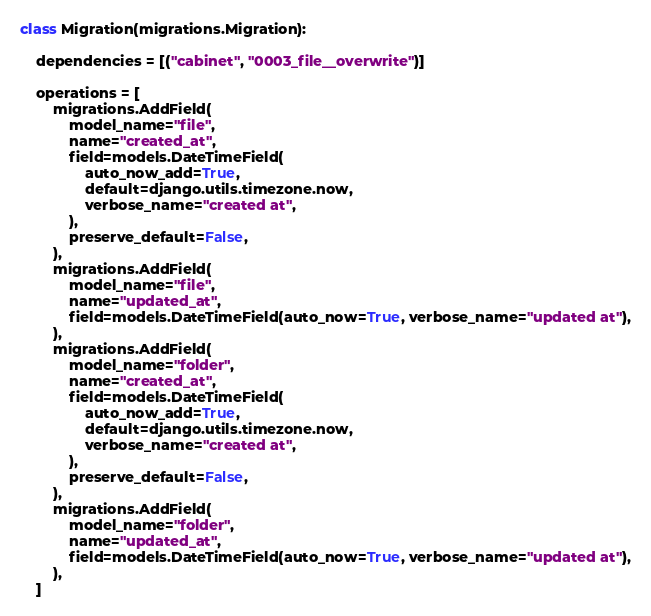<code> <loc_0><loc_0><loc_500><loc_500><_Python_>

class Migration(migrations.Migration):

    dependencies = [("cabinet", "0003_file__overwrite")]

    operations = [
        migrations.AddField(
            model_name="file",
            name="created_at",
            field=models.DateTimeField(
                auto_now_add=True,
                default=django.utils.timezone.now,
                verbose_name="created at",
            ),
            preserve_default=False,
        ),
        migrations.AddField(
            model_name="file",
            name="updated_at",
            field=models.DateTimeField(auto_now=True, verbose_name="updated at"),
        ),
        migrations.AddField(
            model_name="folder",
            name="created_at",
            field=models.DateTimeField(
                auto_now_add=True,
                default=django.utils.timezone.now,
                verbose_name="created at",
            ),
            preserve_default=False,
        ),
        migrations.AddField(
            model_name="folder",
            name="updated_at",
            field=models.DateTimeField(auto_now=True, verbose_name="updated at"),
        ),
    ]
</code> 